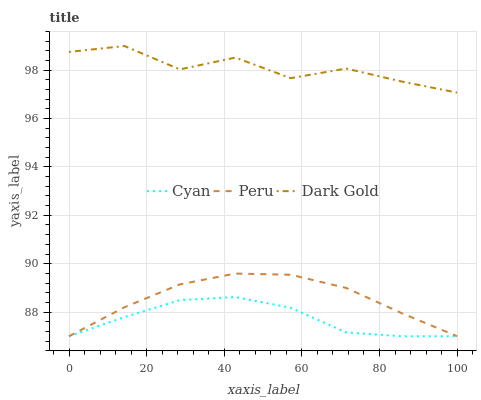Does Cyan have the minimum area under the curve?
Answer yes or no. Yes. Does Dark Gold have the maximum area under the curve?
Answer yes or no. Yes. Does Peru have the minimum area under the curve?
Answer yes or no. No. Does Peru have the maximum area under the curve?
Answer yes or no. No. Is Peru the smoothest?
Answer yes or no. Yes. Is Dark Gold the roughest?
Answer yes or no. Yes. Is Dark Gold the smoothest?
Answer yes or no. No. Is Peru the roughest?
Answer yes or no. No. Does Cyan have the lowest value?
Answer yes or no. Yes. Does Dark Gold have the lowest value?
Answer yes or no. No. Does Dark Gold have the highest value?
Answer yes or no. Yes. Does Peru have the highest value?
Answer yes or no. No. Is Cyan less than Dark Gold?
Answer yes or no. Yes. Is Dark Gold greater than Peru?
Answer yes or no. Yes. Does Peru intersect Cyan?
Answer yes or no. Yes. Is Peru less than Cyan?
Answer yes or no. No. Is Peru greater than Cyan?
Answer yes or no. No. Does Cyan intersect Dark Gold?
Answer yes or no. No. 